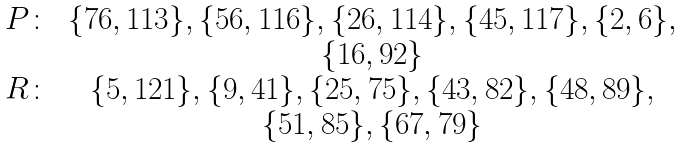Convert formula to latex. <formula><loc_0><loc_0><loc_500><loc_500>\begin{array} { c c c } P \colon & \{ 7 6 , 1 1 3 \} , \{ 5 6 , 1 1 6 \} , \{ 2 6 , 1 1 4 \} , \{ 4 5 , 1 1 7 \} , \{ 2 , 6 \} , \\ & \{ 1 6 , 9 2 \} \\ R \colon & \{ 5 , 1 2 1 \} , \{ 9 , 4 1 \} , \{ 2 5 , 7 5 \} , \{ 4 3 , 8 2 \} , \{ 4 8 , 8 9 \} , \\ & \{ 5 1 , 8 5 \} , \{ 6 7 , 7 9 \} \\ \end{array}</formula> 